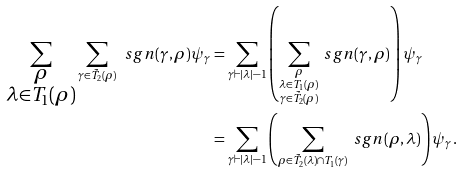Convert formula to latex. <formula><loc_0><loc_0><loc_500><loc_500>\sum _ { \substack { \rho \\ \lambda \in T _ { 1 } ( \rho ) } } \sum _ { \gamma \in \tilde { T } _ { 2 } ( \rho ) } \ s g n ( \gamma , \rho ) \psi _ { \gamma } & = \sum _ { \gamma \vdash | \lambda | - 1 } \left ( \sum _ { \substack { \rho \\ \lambda \in T _ { 1 } ( \rho ) \\ \gamma \in \tilde { T } _ { 2 } ( \rho ) } } \ s g n ( \gamma , \rho ) \right ) \psi _ { \gamma } \\ & = \sum _ { \gamma \vdash | \lambda | - 1 } \left ( \sum _ { \rho \in \tilde { T } _ { 2 } ( \lambda ) \cap T _ { 1 } ( \gamma ) } \ s g n ( \rho , \lambda ) \right ) \psi _ { \gamma } .</formula> 